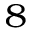<formula> <loc_0><loc_0><loc_500><loc_500>^ { 8 }</formula> 